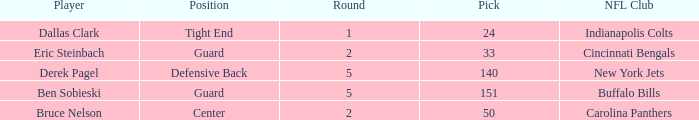During which round was a Hawkeyes player selected for the defensive back position? 5.0. 